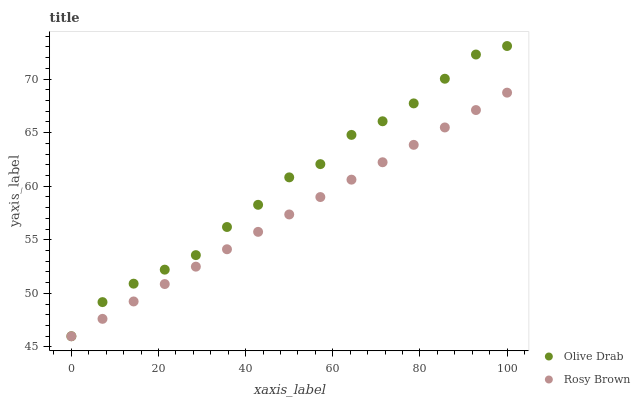Does Rosy Brown have the minimum area under the curve?
Answer yes or no. Yes. Does Olive Drab have the maximum area under the curve?
Answer yes or no. Yes. Does Olive Drab have the minimum area under the curve?
Answer yes or no. No. Is Rosy Brown the smoothest?
Answer yes or no. Yes. Is Olive Drab the roughest?
Answer yes or no. Yes. Is Olive Drab the smoothest?
Answer yes or no. No. Does Rosy Brown have the lowest value?
Answer yes or no. Yes. Does Olive Drab have the highest value?
Answer yes or no. Yes. Does Olive Drab intersect Rosy Brown?
Answer yes or no. Yes. Is Olive Drab less than Rosy Brown?
Answer yes or no. No. Is Olive Drab greater than Rosy Brown?
Answer yes or no. No. 